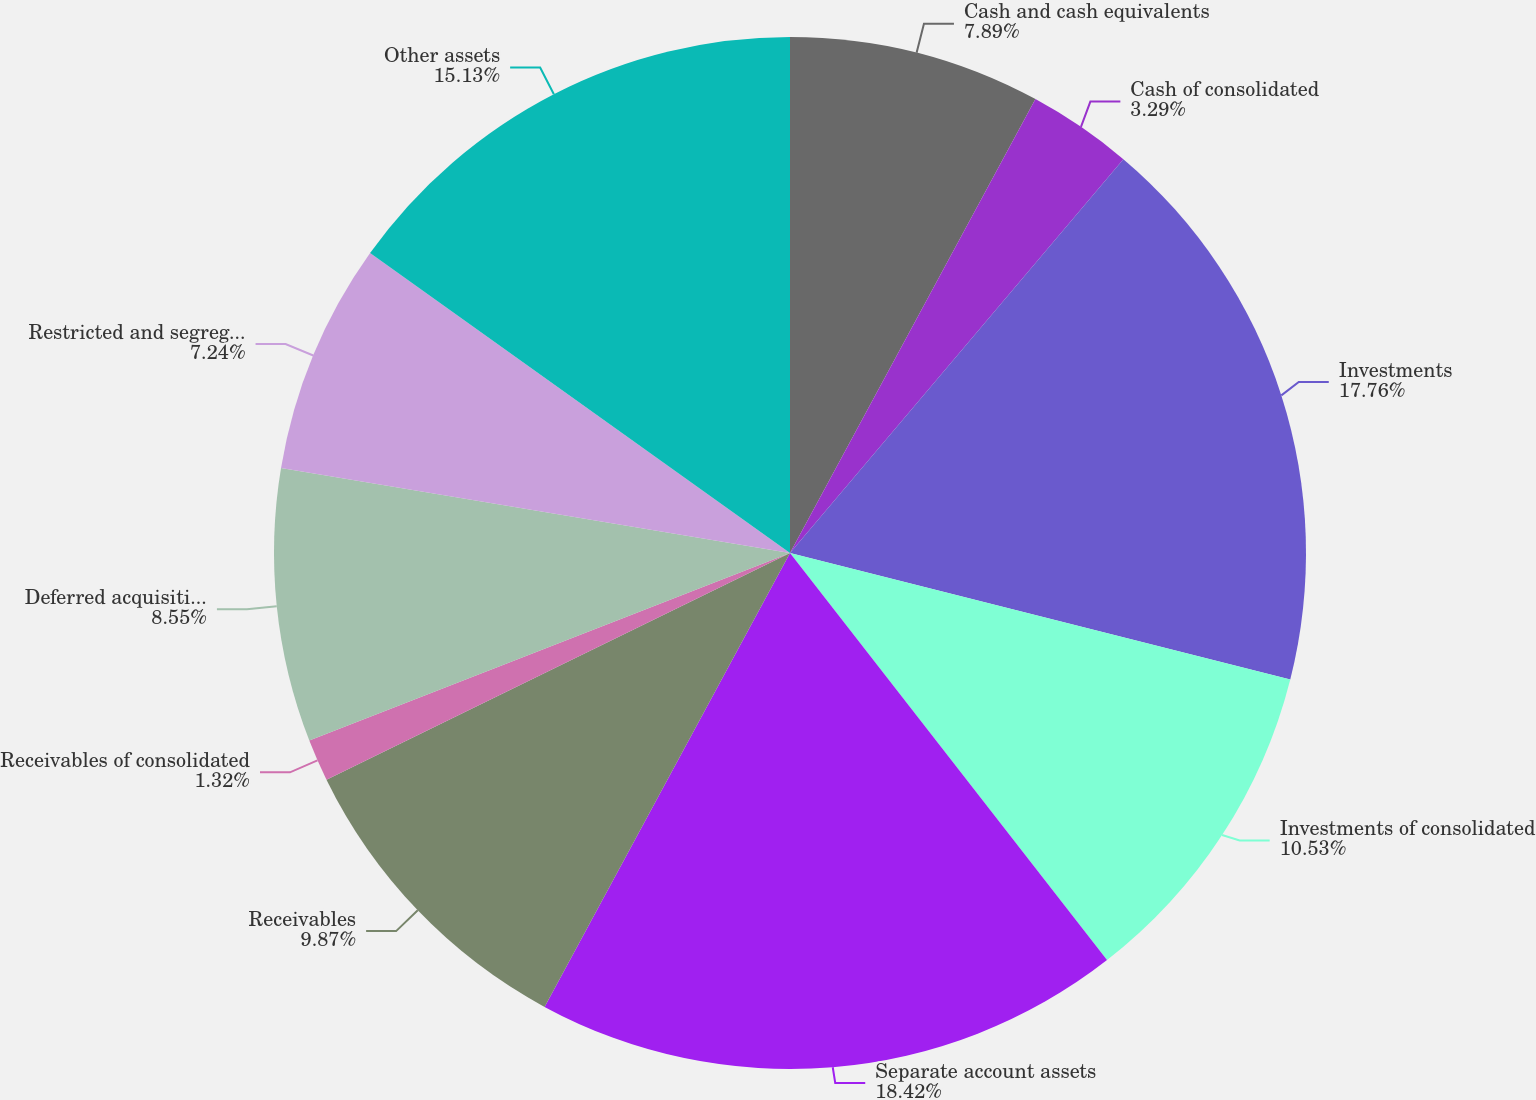Convert chart to OTSL. <chart><loc_0><loc_0><loc_500><loc_500><pie_chart><fcel>Cash and cash equivalents<fcel>Cash of consolidated<fcel>Investments<fcel>Investments of consolidated<fcel>Separate account assets<fcel>Receivables<fcel>Receivables of consolidated<fcel>Deferred acquisition costs<fcel>Restricted and segregated cash<fcel>Other assets<nl><fcel>7.89%<fcel>3.29%<fcel>17.76%<fcel>10.53%<fcel>18.42%<fcel>9.87%<fcel>1.32%<fcel>8.55%<fcel>7.24%<fcel>15.13%<nl></chart> 